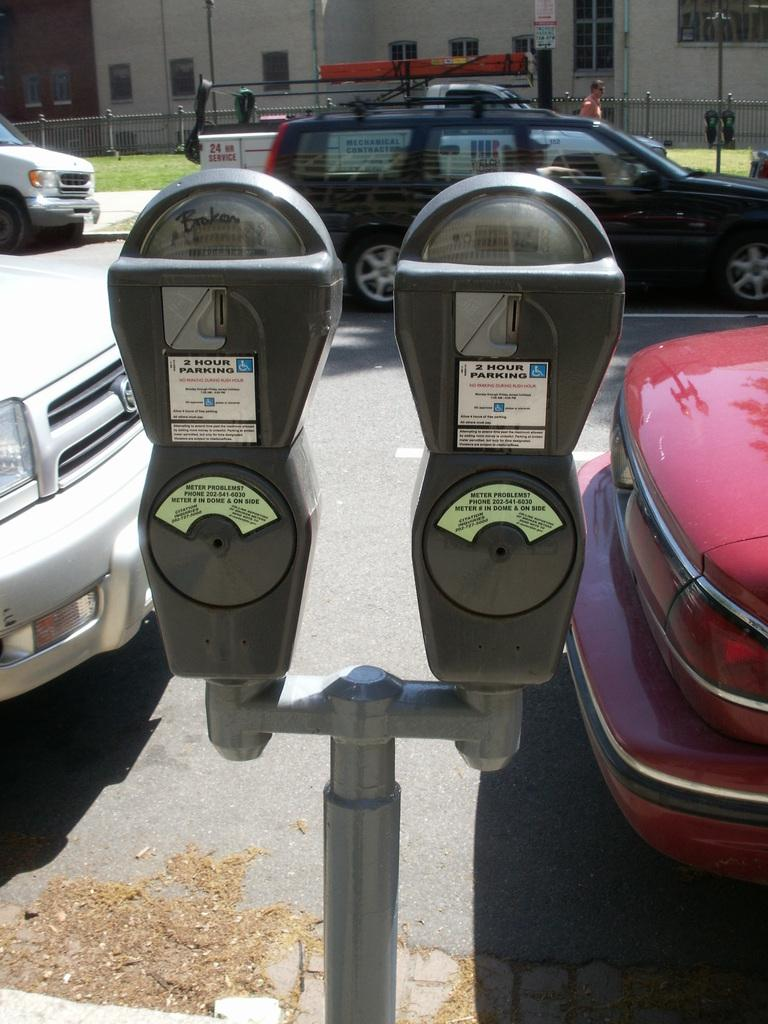<image>
Relay a brief, clear account of the picture shown. Two parking meters that claim two hour parking are on the side of a road. 